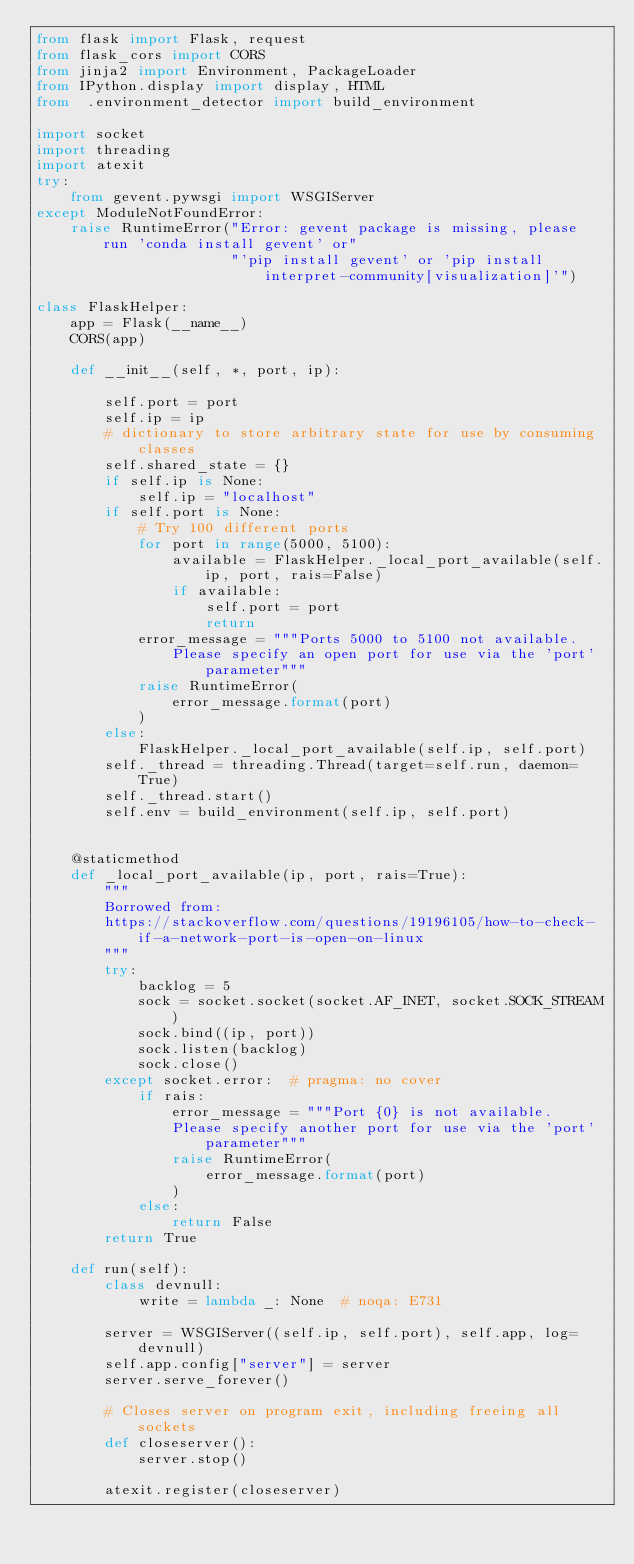Convert code to text. <code><loc_0><loc_0><loc_500><loc_500><_Python_>from flask import Flask, request
from flask_cors import CORS
from jinja2 import Environment, PackageLoader
from IPython.display import display, HTML
from  .environment_detector import build_environment

import socket
import threading
import atexit
try:
    from gevent.pywsgi import WSGIServer
except ModuleNotFoundError:
    raise RuntimeError("Error: gevent package is missing, please run 'conda install gevent' or"
                       "'pip install gevent' or 'pip install interpret-community[visualization]'")

class FlaskHelper:
    app = Flask(__name__)
    CORS(app)

    def __init__(self, *, port, ip):

        self.port = port
        self.ip = ip
        # dictionary to store arbitrary state for use by consuming classes
        self.shared_state = {}
        if self.ip is None:
            self.ip = "localhost"
        if self.port is None:
            # Try 100 different ports
            for port in range(5000, 5100):
                available = FlaskHelper._local_port_available(self.ip, port, rais=False)
                if available:
                    self.port = port
                    return
            error_message = """Ports 5000 to 5100 not available.
                Please specify an open port for use via the 'port' parameter"""
            raise RuntimeError(
                error_message.format(port)
            )
        else:
            FlaskHelper._local_port_available(self.ip, self.port)
        self._thread = threading.Thread(target=self.run, daemon=True)
        self._thread.start()
        self.env = build_environment(self.ip, self.port)
        

    @staticmethod
    def _local_port_available(ip, port, rais=True):
        """
        Borrowed from:
        https://stackoverflow.com/questions/19196105/how-to-check-if-a-network-port-is-open-on-linux
        """
        try:
            backlog = 5
            sock = socket.socket(socket.AF_INET, socket.SOCK_STREAM)
            sock.bind((ip, port))
            sock.listen(backlog)
            sock.close()
        except socket.error:  # pragma: no cover
            if rais:
                error_message = """Port {0} is not available.
                Please specify another port for use via the 'port' parameter"""
                raise RuntimeError(
                    error_message.format(port)
                )
            else:
                return False
        return True
    
    def run(self):
        class devnull:
            write = lambda _: None  # noqa: E731

        server = WSGIServer((self.ip, self.port), self.app, log=devnull)
        self.app.config["server"] = server
        server.serve_forever()

        # Closes server on program exit, including freeing all sockets
        def closeserver():
            server.stop()

        atexit.register(closeserver)</code> 